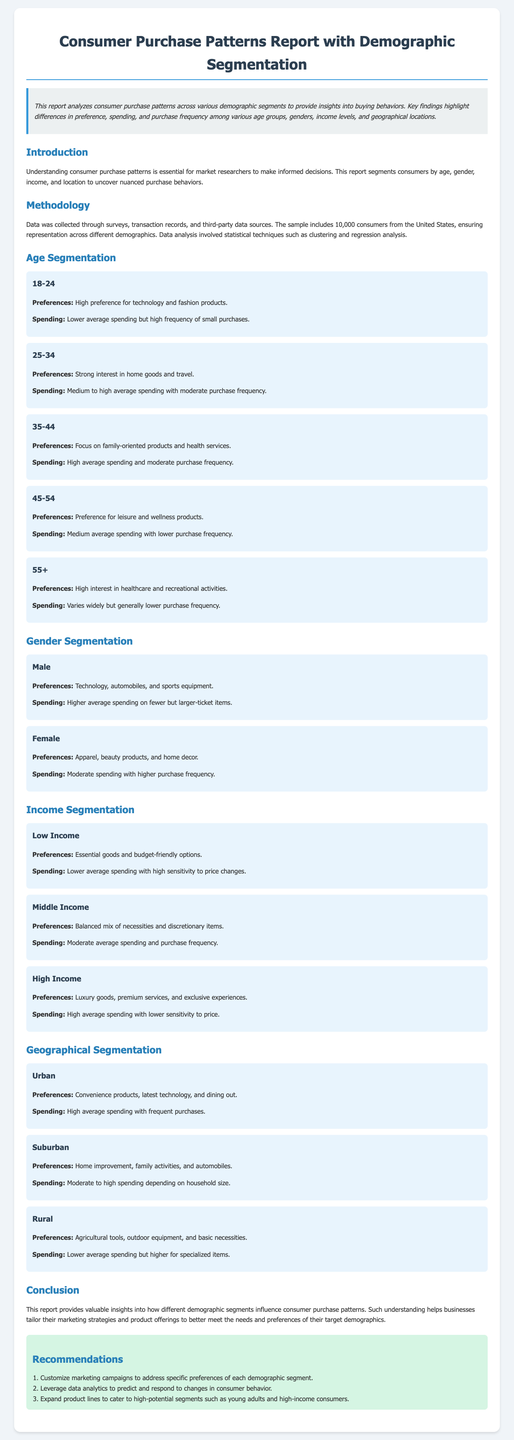what is the sample size of consumers analyzed in the report? The sample size mentioned in the document is 10,000 consumers.
Answer: 10,000 consumers which age group has the highest average spending? The age group 35-44 is noted for having high average spending.
Answer: 35-44 what product category do females prefer according to the gender segmentation? The document states that females prefer apparel, beauty products, and home decor.
Answer: Apparel, beauty products, and home decor what is the income level with the highest price sensitivity? The low-income segment displays high sensitivity to price changes.
Answer: Low Income which demographic segment shows a strong interest in healthcare products? The age group 55+ is highlighted for having high interest in healthcare products.
Answer: 55+ what recommendations are made for customizing marketing campaigns? The recommendation suggests customizing marketing campaigns to address preferences of each demographic segment.
Answer: Customize marketing campaigns what type of products is preferred by urban consumers? Urban consumers prefer convenience products, latest technology, and dining out.
Answer: Convenience products, latest technology, and dining out what is the spending behavior of high-income consumers? High-income consumers are characterized by high average spending with lower sensitivity to price.
Answer: High average spending what geographical area shows a preference for agricultural tools? Rural consumers are noted for their preference for agricultural tools.
Answer: Rural 